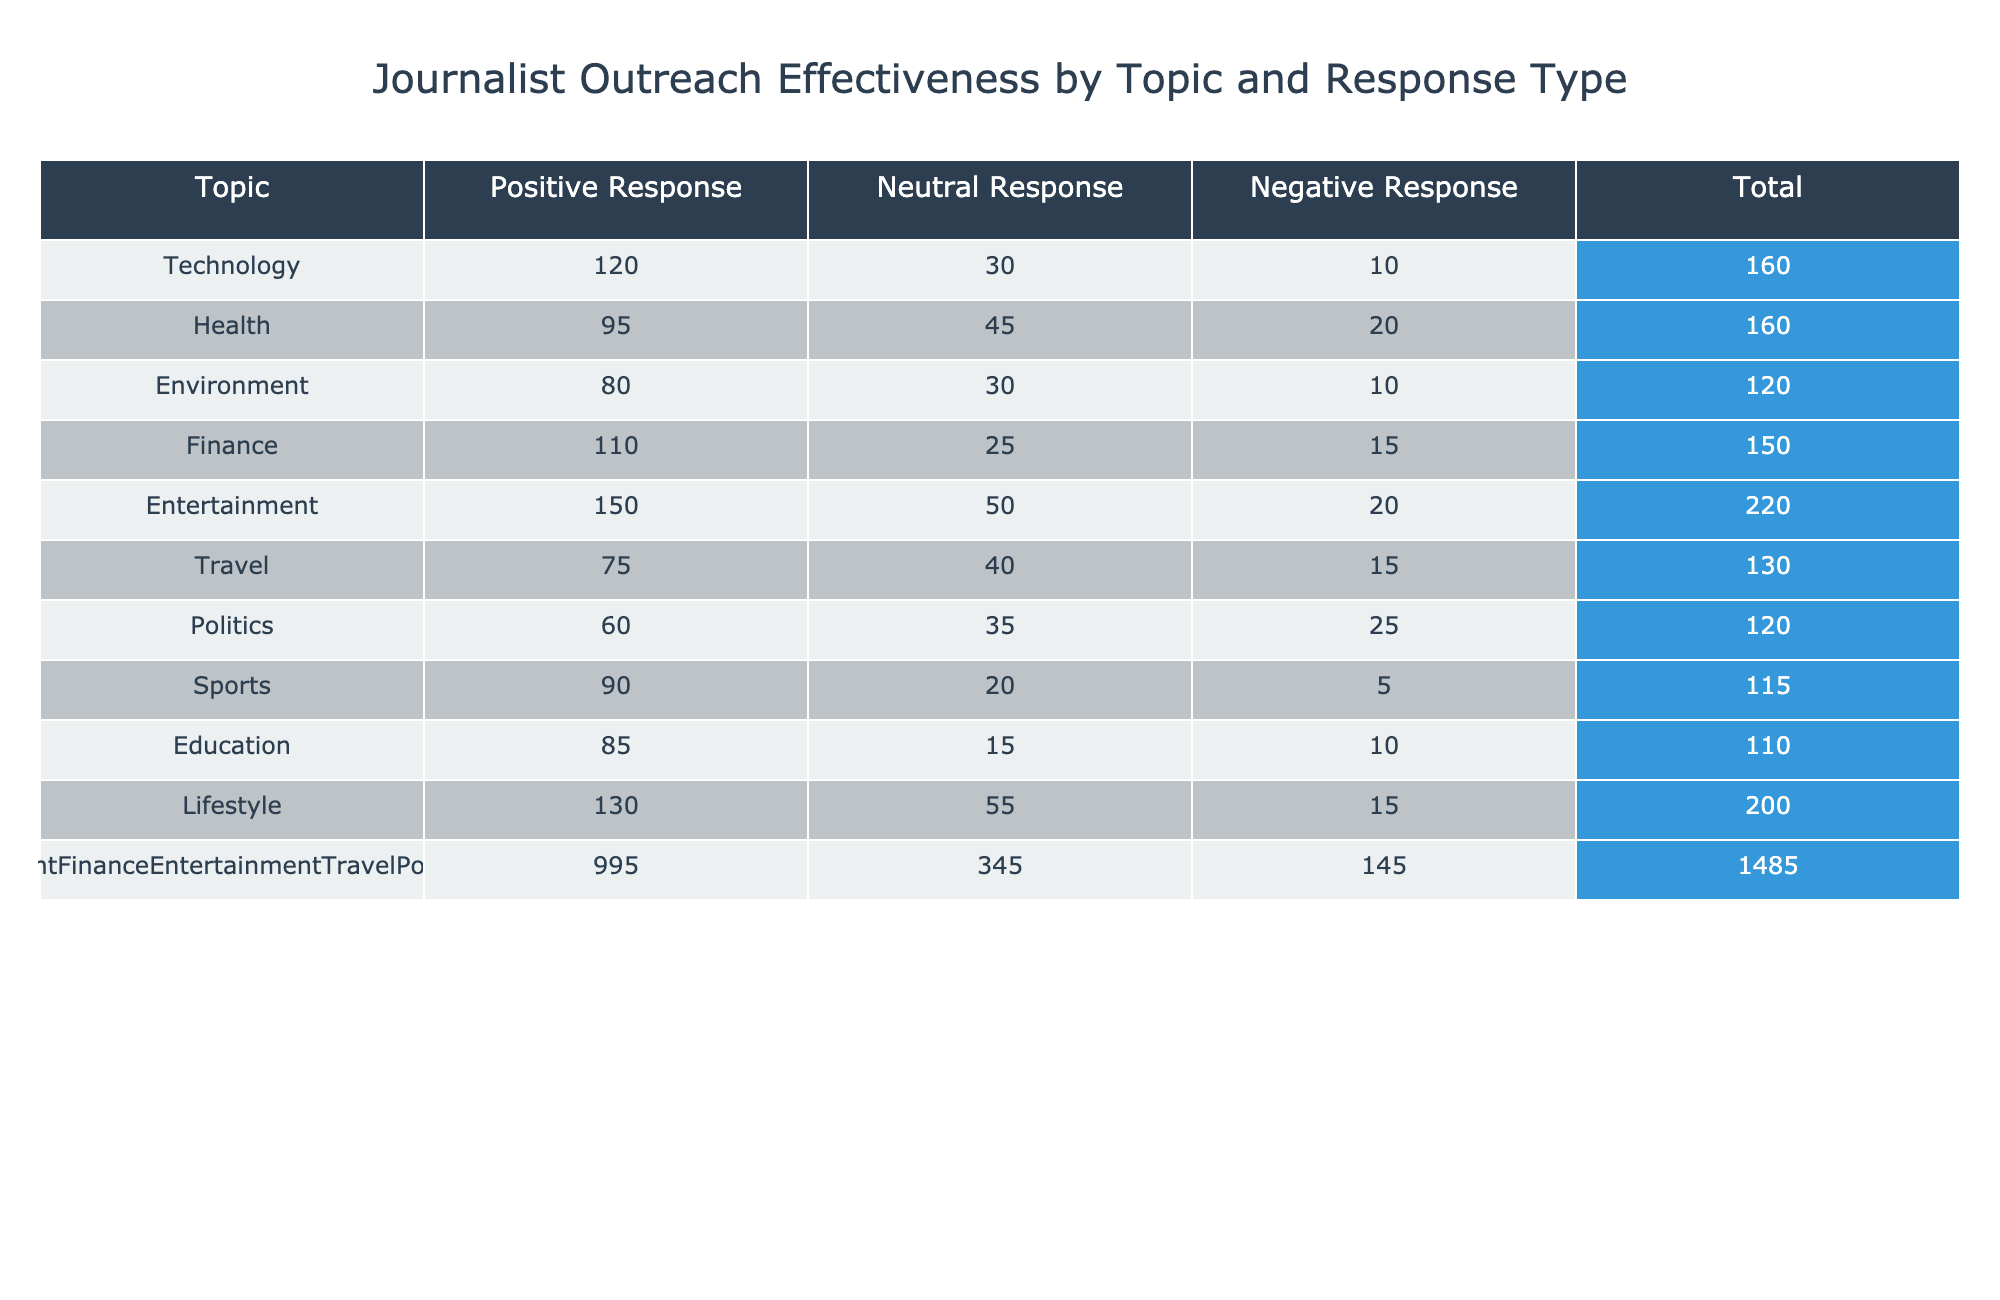What topic received the highest positive response? The table indicates that the topic "Entertainment" has the highest positive response count of 150. This was determined by comparing the values in the "Positive Response" column for each topic.
Answer: Entertainment What is the total number of responses for the topic "Finance"? To find the total responses for the topic "Finance," we sum the positive, neutral, and negative responses: 110 (Positive) + 25 (Neutral) + 15 (Negative) = 150.
Answer: 150 Is the number of positive responses for "Politics" greater than the number of negative responses for "Environment"? The positive responses for "Politics" is 60, and the negative responses for "Environment" is 10. Since 60 is greater than 10, the statement is true.
Answer: Yes What is the average number of neutral responses across all topics? First, we need to sum all neutral responses: 30 + 45 + 30 + 25 + 50 + 40 + 35 + 20 + 15 + 55 =  400. Then divide by the number of topics, which is 10: 400 / 10 = 40.
Answer: 40 Which topic has the least total response? To identify the topic with the least total responses, we can calculate the total for each topic. The topic "Travel" has a total of 75 + 40 + 15 = 130, which is the lowest total when compared to other topics.
Answer: Travel What is the difference in positive responses between "Technology" and "Health"? The positive responses for "Technology" is 120, and for "Health" it is 95. The difference is calculated as 120 - 95 = 25.
Answer: 25 How many topics received a neutral response of more than 40? By examining the "Neutral Response" column, we can see that the topics "Health" (45), "Entertainment" (50), "Travel" (40), and "Lifestyle" (55) all have neutral responses greater than 40. Therefore, there are 4 topics that meet this criterion.
Answer: 4 If we combine the positive and negative responses for "Sports," what is the resultant total? For "Sports," the positive responses are 90 and the negative responses are 5, so the combined total is 90 + 5 = 95.
Answer: 95 Is it true that "Lifestyle" received more positive responses than "Education"? The positive responses for "Lifestyle" is 130, while for "Education" it is 85. Since 130 is greater than 85, the statement is true.
Answer: Yes 